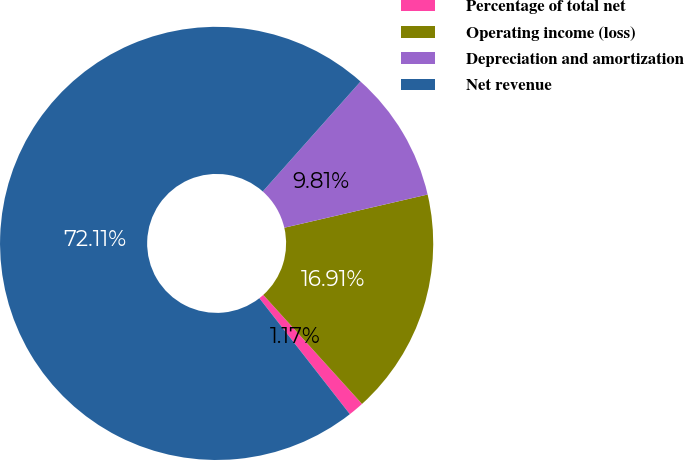<chart> <loc_0><loc_0><loc_500><loc_500><pie_chart><fcel>Percentage of total net<fcel>Operating income (loss)<fcel>Depreciation and amortization<fcel>Net revenue<nl><fcel>1.17%<fcel>16.91%<fcel>9.81%<fcel>72.11%<nl></chart> 